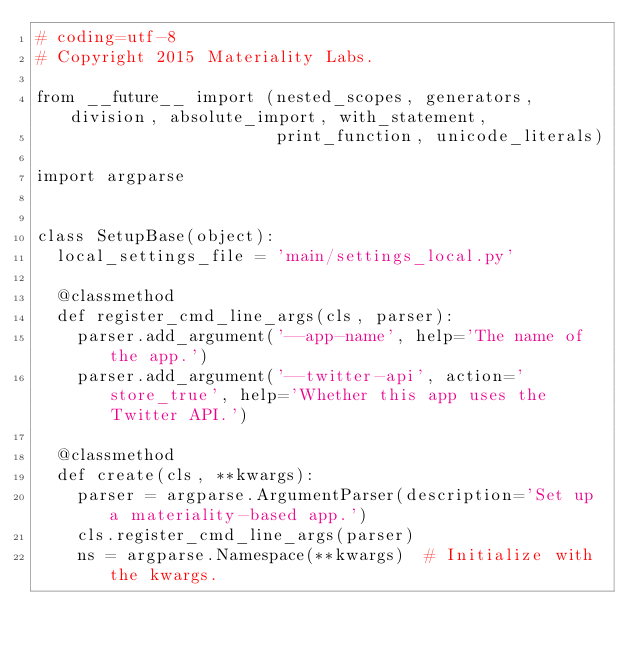<code> <loc_0><loc_0><loc_500><loc_500><_Python_># coding=utf-8
# Copyright 2015 Materiality Labs.

from __future__ import (nested_scopes, generators, division, absolute_import, with_statement,
                        print_function, unicode_literals)

import argparse


class SetupBase(object):
  local_settings_file = 'main/settings_local.py'

  @classmethod
  def register_cmd_line_args(cls, parser):
    parser.add_argument('--app-name', help='The name of the app.')
    parser.add_argument('--twitter-api', action='store_true', help='Whether this app uses the Twitter API.')

  @classmethod
  def create(cls, **kwargs):
    parser = argparse.ArgumentParser(description='Set up a materiality-based app.')
    cls.register_cmd_line_args(parser)
    ns = argparse.Namespace(**kwargs)  # Initialize with the kwargs.</code> 